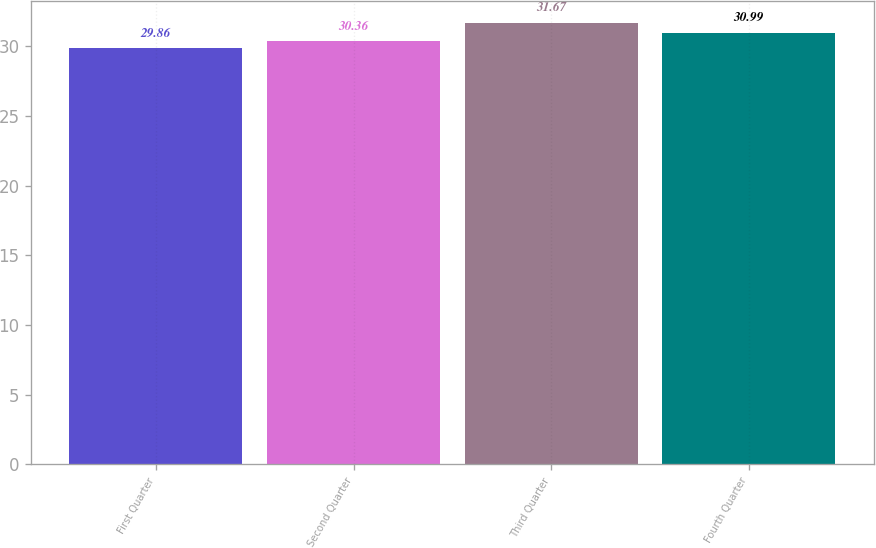Convert chart. <chart><loc_0><loc_0><loc_500><loc_500><bar_chart><fcel>First Quarter<fcel>Second Quarter<fcel>Third Quarter<fcel>Fourth Quarter<nl><fcel>29.86<fcel>30.36<fcel>31.67<fcel>30.99<nl></chart> 